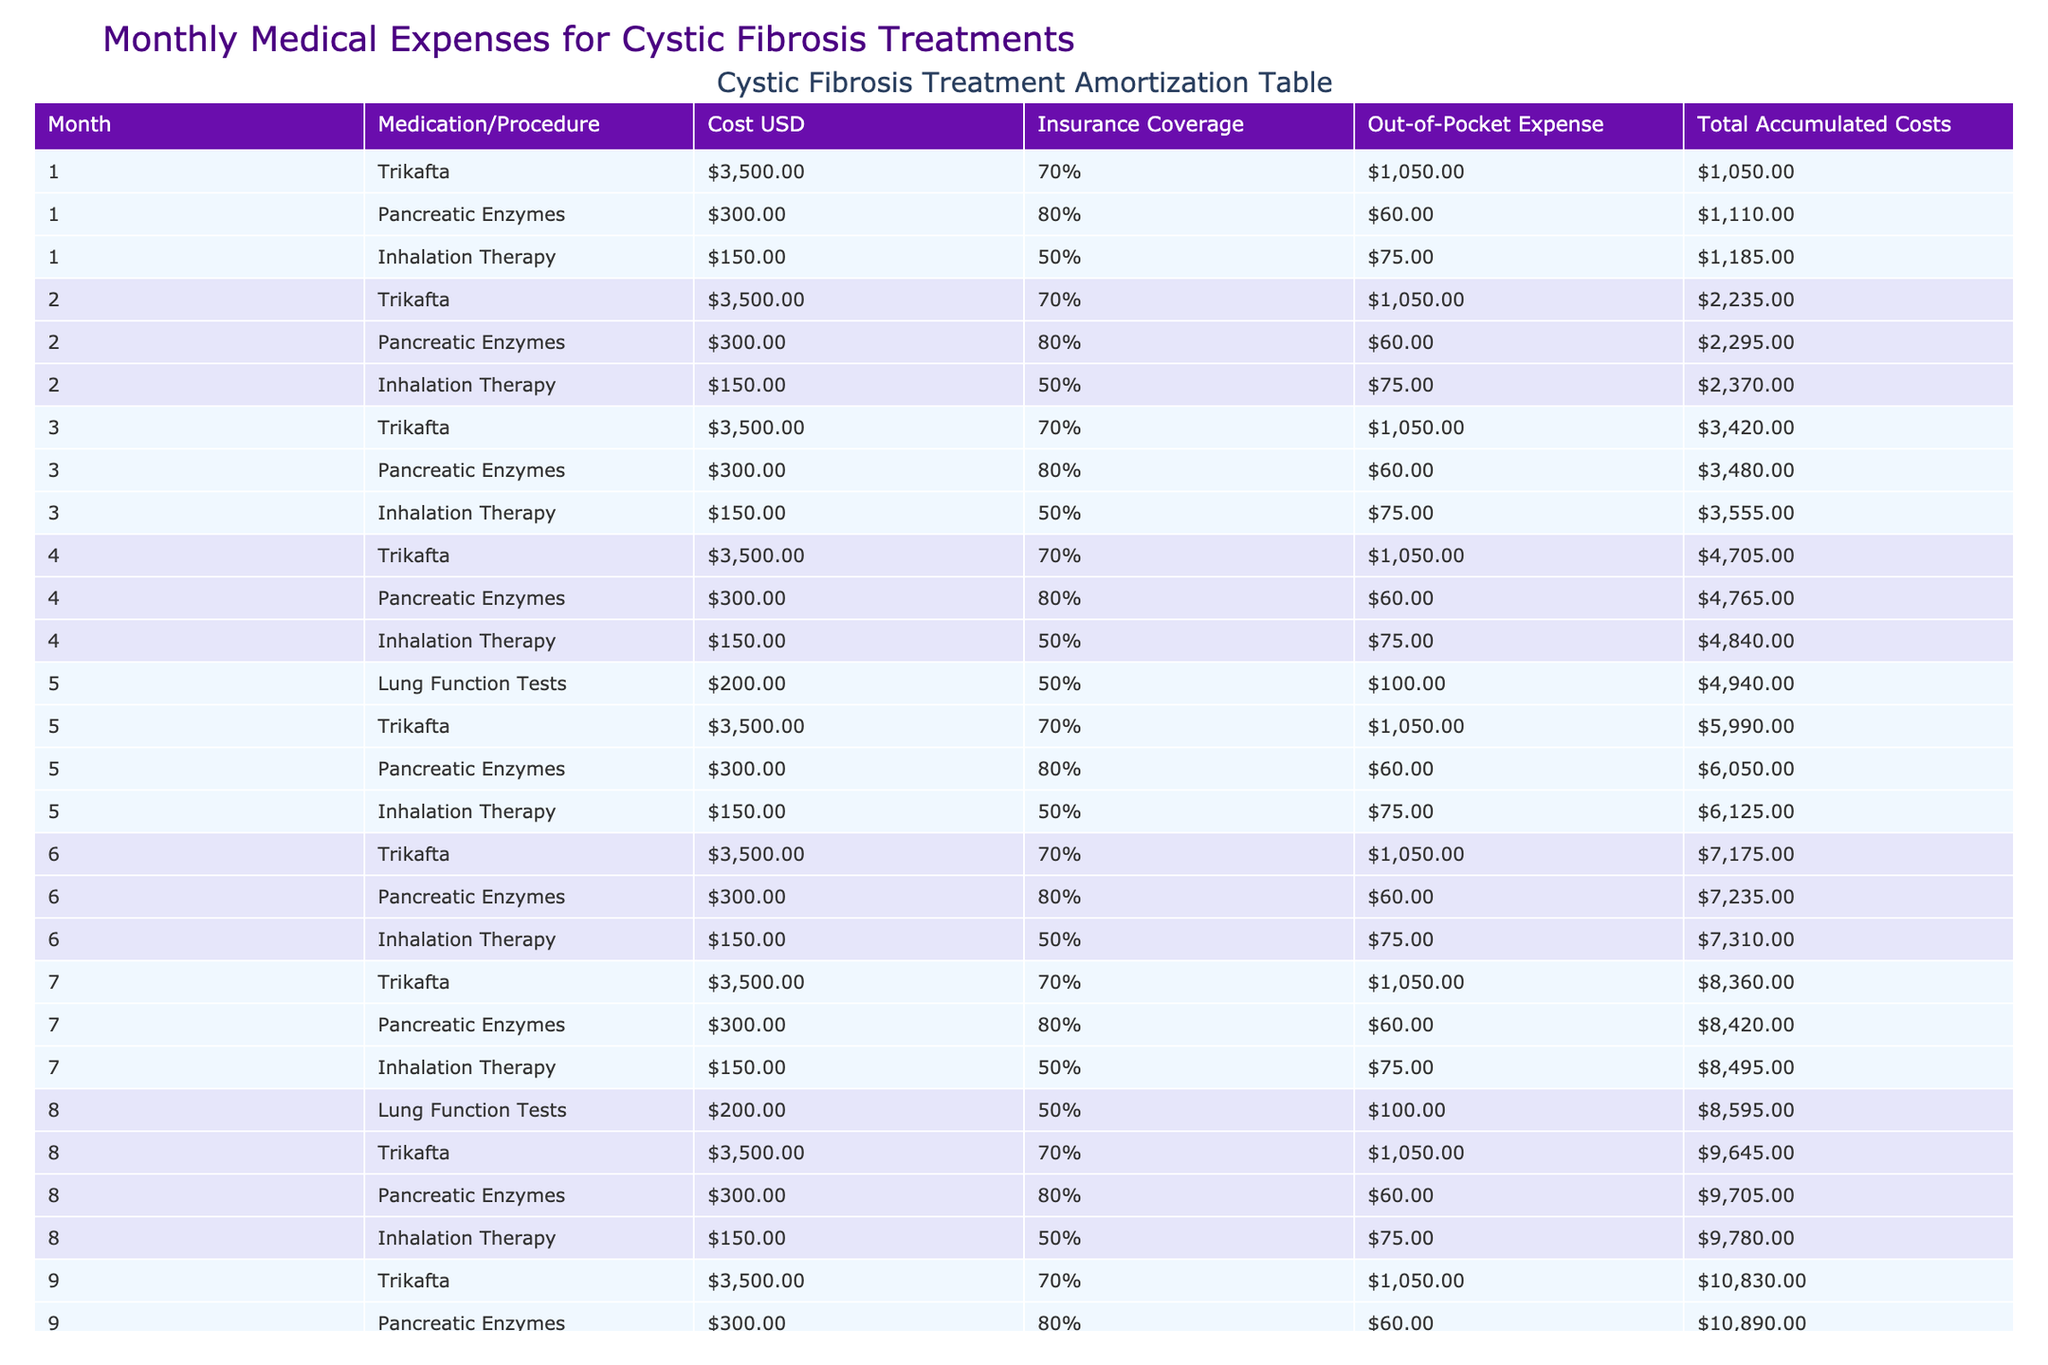What is the total out-of-pocket expense for month 5? In month 5, the table shows three entries: Lung Function Tests with an out-of-pocket expense of $100, Trikafta with an out-of-pocket expense of $1050, Pancreatic Enzymes with $60, and Inhalation Therapy with $75. To find the total, we add these expenses: 100 + 1050 + 60 + 75 = 1285.
Answer: 1285 How much did the total accumulated costs increase from month 1 to month 3? In month 1, the total accumulated cost is $1185, and in month 3, it is $3555. To find the increase, we subtract the cost in month 1 from the cost in month 3: 3555 - 1185 = 2370.
Answer: 2370 Is there any month where the out-of-pocket expense for Inhalation Therapy is $75? Looking through the table, Inhalation Therapy consistently has an out-of-pocket expense of $75 every month listed. Therefore, it is true that there is a month where the out-of-pocket expense is $75 for Inhalation Therapy.
Answer: Yes What is the total cost of Trikafta over the first 12 months? The table shows that the cost of Trikafta is $3500 each month. Since it is administered every month for 12 months, we calculate the total cost as 3500 multiplied by 12, which equals 42000.
Answer: 42000 In which month does the total accumulated cost exceed $10,000 for the first time? Scanning the table, the total accumulated cost reaches $10,830 in month 9, and the previous month (month 8) is $9780, which is below $10,000. Consequently, month 9 is the first month where the total accumulated cost exceeds $10,000.
Answer: Month 9 